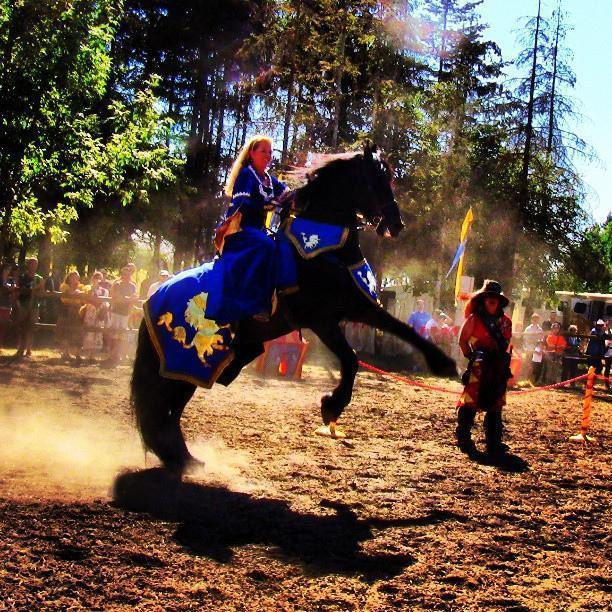How many people are there?
Give a very brief answer. 3. 